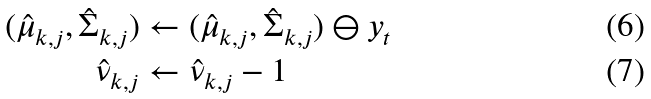<formula> <loc_0><loc_0><loc_500><loc_500>( \hat { \mu } _ { k , j } , \hat { \Sigma } _ { k , j } ) & \leftarrow ( \hat { \mu } _ { k , j } , \hat { \Sigma } _ { k , j } ) \ominus y _ { t } \\ \hat { \nu } _ { k , j } & \leftarrow \hat { \nu } _ { k , j } - 1</formula> 